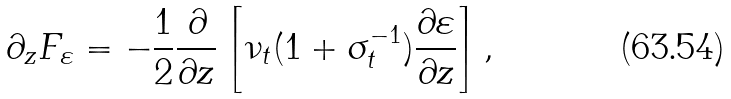<formula> <loc_0><loc_0><loc_500><loc_500>\partial _ { z } F _ { \varepsilon } = - \frac { 1 } { 2 } \frac { \partial } { \partial z } \left [ \nu _ { t } ( 1 + \sigma _ { t } ^ { - 1 } ) \frac { \partial \varepsilon } { \partial z } \right ] ,</formula> 